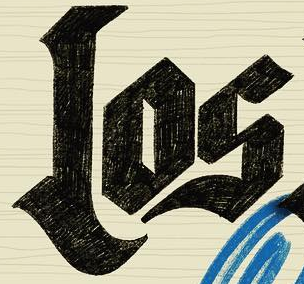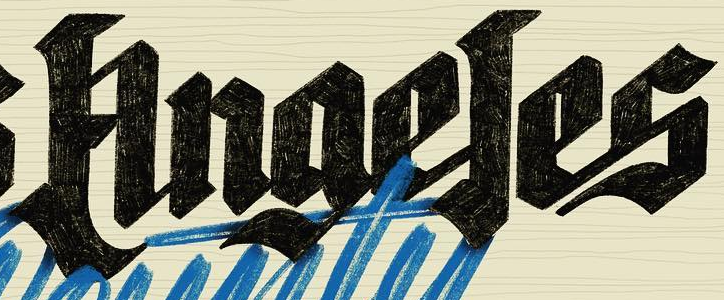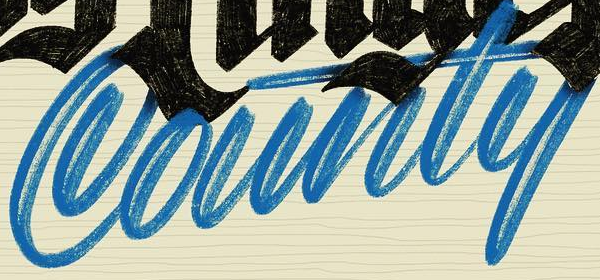What text appears in these images from left to right, separated by a semicolon? Los; Anaeles; County 